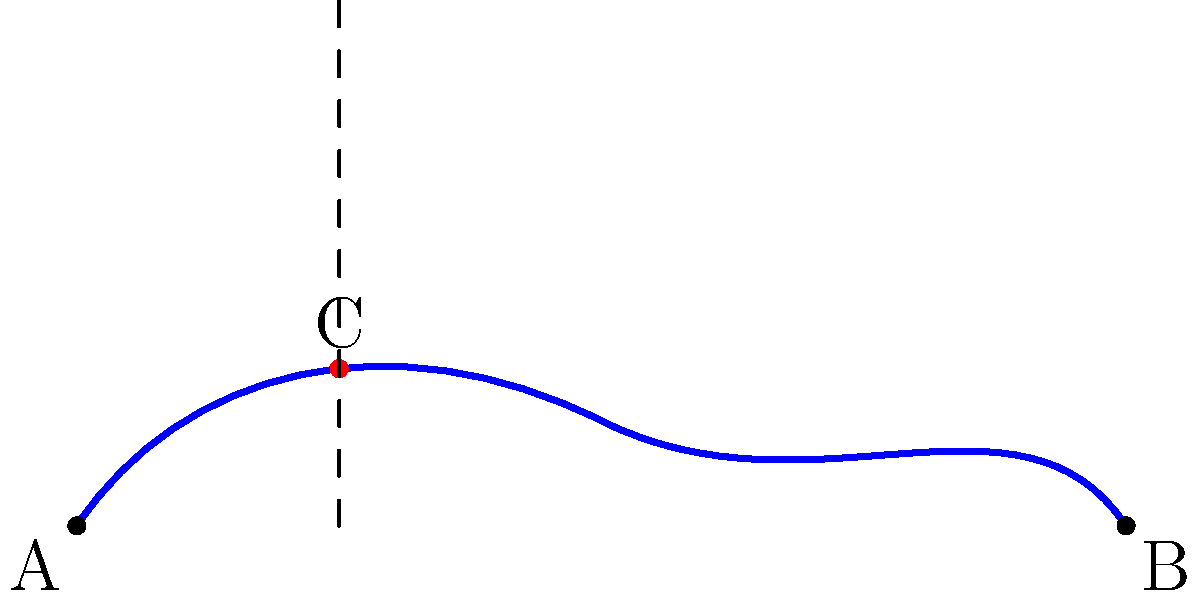A historic canal in the city's old district follows a winding path from point A to point B, as shown in the diagram. The straight-line distance between A and B is 200 meters. At point C, which is 50 meters from A when measured horizontally, the canal reaches its maximum curvature. If the radius of curvature at point C is 40 meters, what is the approximate length of the entire canal path from A to B? To solve this problem, we'll use the concept of arc length and approximate the canal's path as a circular arc:

1) First, we need to find the central angle θ of the circular arc. We can do this using the equation:

   $$\cos(\theta/2) = \frac{\text{chord length}}{2 * \text{radius}}$$

2) The chord length is the straight-line distance AB, which is 200 meters. The radius at point C is 40 meters. Substituting these values:

   $$\cos(\theta/2) = \frac{200}{2 * 40} = 2.5$$

3) However, this is impossible as cosine can't be greater than 1. This means our canal can't be approximated by a single circular arc.

4) Instead, let's approximate it as two circular arcs, each with radius 40 meters. The central angle for each arc would be:

   $$\cos(\theta/2) = \frac{100}{2 * 40} = 1.25$$
   $$\theta = 2 * \arccos(1.25) \approx 2.214 \text{ radians}$$

5) The length of each arc would be:

   $$\text{arc length} = r * \theta = 40 * 2.214 \approx 88.56 \text{ meters}$$

6) The total length of the canal would be approximately twice this:

   $$\text{total length} \approx 2 * 88.56 = 177.12 \text{ meters}$$

This is an approximation, as the actual canal likely has varying curvature along its length, but it gives a reasonable estimate based on the information provided.
Answer: Approximately 177 meters 